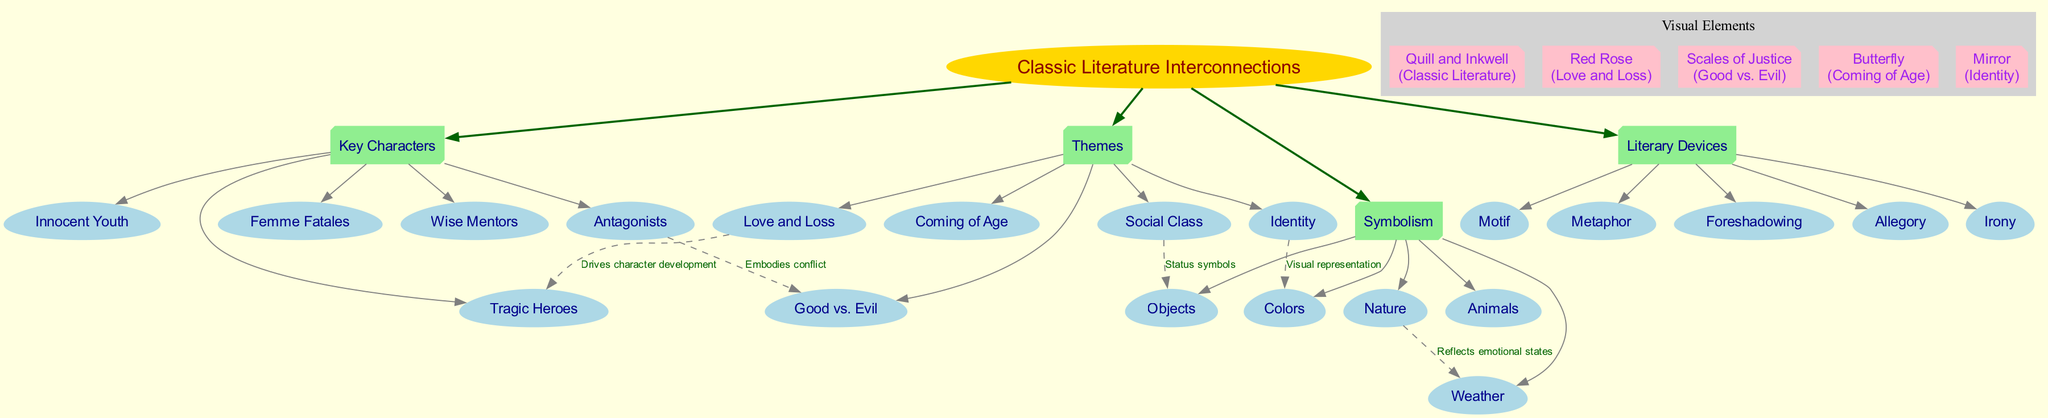What's the central theme of the diagram? The diagram clearly states that the central theme is "Classic Literature Interconnections", which is depicted as the main ellipse in the center of the diagram.
Answer: Classic Literature Interconnections How many main branches are there? The diagram features four main branches extending from the central theme: Themes, Symbolism, Key Characters, and Literary Devices, as counted visually.
Answer: 4 Which sub-branch is connected to "Tragic Heroes"? The connection shows that "Tragic Heroes" is linked to the sub-branch "Love and Loss", indicating a direct relationship between these two concepts in the diagram.
Answer: Love and Loss What symbolizes "Identity" in the visual elements? The visual element labeled as "Mirror" represents the theme of Identity, as indicated in the section where visual elements are clustered together.
Answer: Mirror Which literary device is associated with "Foreshadowing"? The cluster of Literary Devices indicates that "Foreshadowing" is part of that category. It can be confirmed by the listing shown under the Literary Devices branch.
Answer: Foreshadowing How does "Nature" relate to "Weather"? The diagram shows a dashed connection, indicating that "Nature" reflects emotional states through the concept of "Weather", providing an explanation of their link.
Answer: Reflects emotional states What do "Scales of Justice" represent? The visual elements include "Scales of Justice," which are identified as representing the theme of "Good vs. Evil”, linking it to the ideological conflict.
Answer: Good vs. Evil Which motif represents "Coming of Age"? The sub-branch that correlates with the concept of "Coming of Age" is the "Butterfly," as indicated in the visual elements section.
Answer: Butterfly 